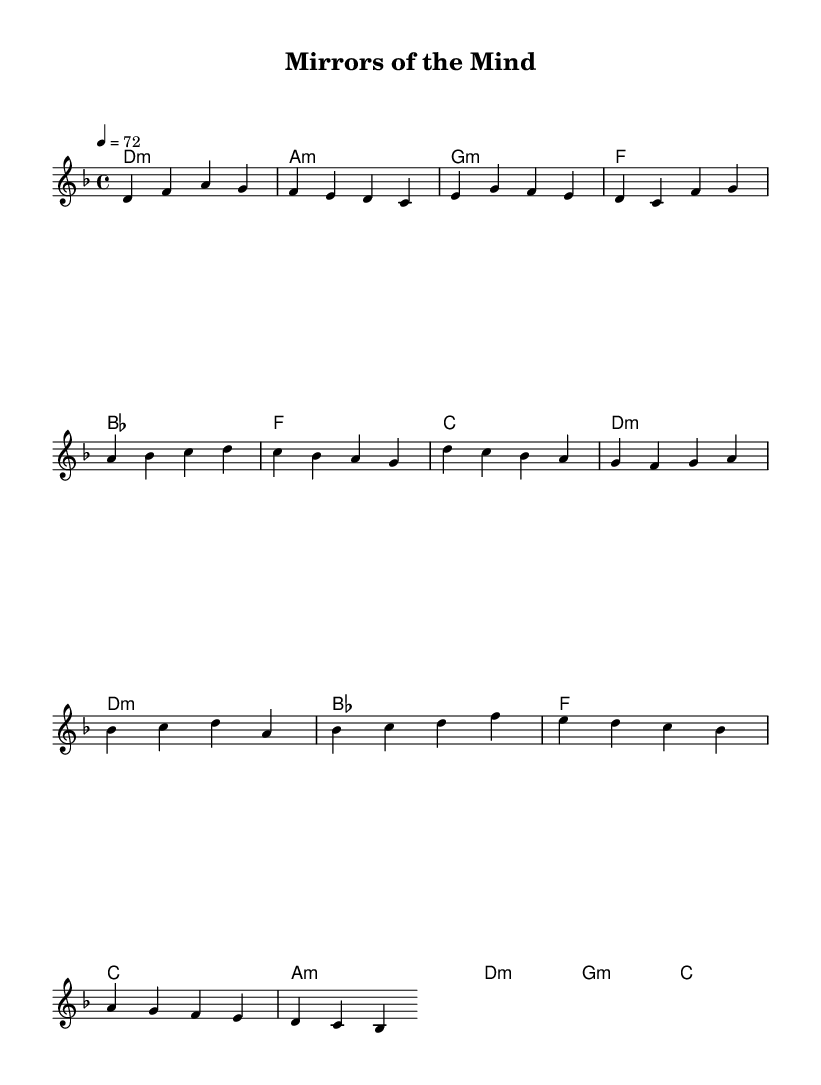What is the key signature of this music? The key signature is D minor, which has one flat (B♭).
Answer: D minor What is the time signature of this music? The time signature is 4/4, indicating four beats per measure.
Answer: 4/4 What is the tempo marking for this piece? The tempo marking is quarter note equals 72 beats per minute.
Answer: 72 What is the first chord used in the verse? The first chord in the verse is D minor, noted as "d1:m" in the chord progression.
Answer: D minor How many measures are in the chorus section? The chorus section consists of four measures, which can be counted from the melody and harmonies written for that section.
Answer: 4 What is the emotional theme reflected in the title "Mirrors of the Mind"? The title suggests introspection and self-reflection, common themes in introspective pop ballads.
Answer: Introspection How does the harmonic progression change from the verse to the pre-chorus? The harmonic progression shifts from minor chords in the verse to a mix of major and minor chords in the pre-chorus, creating tension.
Answer: Minor to mixed 